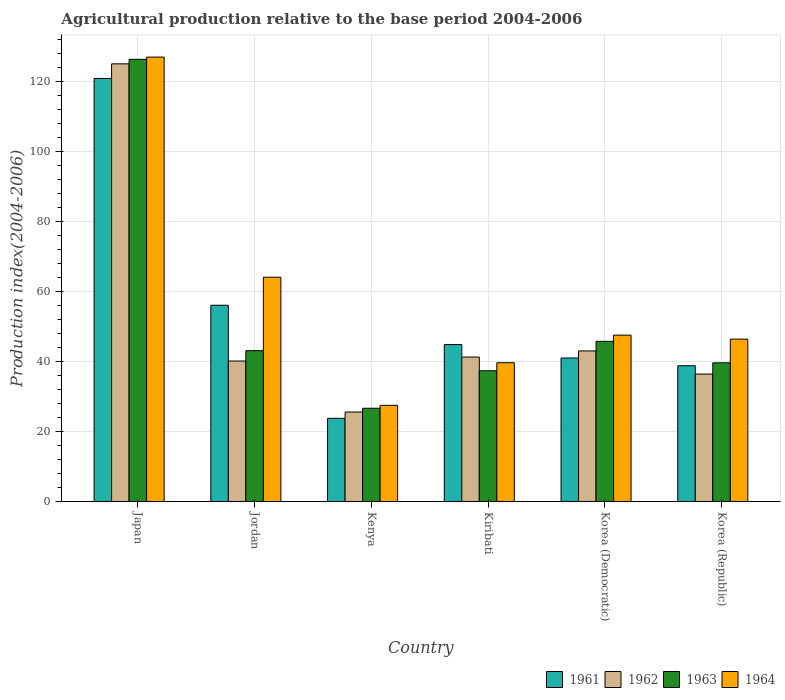How many different coloured bars are there?
Provide a succinct answer. 4. How many bars are there on the 2nd tick from the left?
Provide a short and direct response. 4. What is the label of the 2nd group of bars from the left?
Offer a very short reply. Jordan. Across all countries, what is the maximum agricultural production index in 1964?
Provide a short and direct response. 126.92. Across all countries, what is the minimum agricultural production index in 1964?
Offer a very short reply. 27.46. In which country was the agricultural production index in 1962 minimum?
Give a very brief answer. Kenya. What is the total agricultural production index in 1964 in the graph?
Your answer should be compact. 351.95. What is the difference between the agricultural production index in 1963 in Jordan and that in Korea (Democratic)?
Offer a terse response. -2.67. What is the difference between the agricultural production index in 1962 in Japan and the agricultural production index in 1961 in Korea (Republic)?
Ensure brevity in your answer.  86.22. What is the average agricultural production index in 1962 per country?
Keep it short and to the point. 51.88. What is the difference between the agricultural production index of/in 1962 and agricultural production index of/in 1961 in Korea (Republic)?
Provide a short and direct response. -2.38. What is the ratio of the agricultural production index in 1962 in Japan to that in Jordan?
Provide a short and direct response. 3.12. Is the agricultural production index in 1962 in Japan less than that in Kenya?
Keep it short and to the point. No. What is the difference between the highest and the second highest agricultural production index in 1962?
Your answer should be compact. -1.75. What is the difference between the highest and the lowest agricultural production index in 1961?
Provide a short and direct response. 97.07. Is it the case that in every country, the sum of the agricultural production index in 1963 and agricultural production index in 1962 is greater than the sum of agricultural production index in 1964 and agricultural production index in 1961?
Give a very brief answer. No. What does the 4th bar from the left in Kenya represents?
Provide a short and direct response. 1964. Is it the case that in every country, the sum of the agricultural production index in 1962 and agricultural production index in 1961 is greater than the agricultural production index in 1963?
Your answer should be very brief. Yes. What is the difference between two consecutive major ticks on the Y-axis?
Offer a terse response. 20. Does the graph contain any zero values?
Provide a short and direct response. No. Does the graph contain grids?
Provide a short and direct response. Yes. What is the title of the graph?
Your response must be concise. Agricultural production relative to the base period 2004-2006. Does "1975" appear as one of the legend labels in the graph?
Offer a terse response. No. What is the label or title of the X-axis?
Provide a short and direct response. Country. What is the label or title of the Y-axis?
Ensure brevity in your answer.  Production index(2004-2006). What is the Production index(2004-2006) in 1961 in Japan?
Provide a succinct answer. 120.82. What is the Production index(2004-2006) of 1962 in Japan?
Provide a short and direct response. 124.99. What is the Production index(2004-2006) of 1963 in Japan?
Your answer should be compact. 126.29. What is the Production index(2004-2006) in 1964 in Japan?
Keep it short and to the point. 126.92. What is the Production index(2004-2006) of 1961 in Jordan?
Offer a very short reply. 56.04. What is the Production index(2004-2006) in 1962 in Jordan?
Keep it short and to the point. 40.12. What is the Production index(2004-2006) of 1963 in Jordan?
Provide a short and direct response. 43.07. What is the Production index(2004-2006) of 1964 in Jordan?
Provide a short and direct response. 64.06. What is the Production index(2004-2006) of 1961 in Kenya?
Offer a terse response. 23.75. What is the Production index(2004-2006) in 1962 in Kenya?
Your answer should be compact. 25.55. What is the Production index(2004-2006) in 1963 in Kenya?
Give a very brief answer. 26.63. What is the Production index(2004-2006) of 1964 in Kenya?
Your answer should be very brief. 27.46. What is the Production index(2004-2006) of 1961 in Kiribati?
Your answer should be very brief. 44.81. What is the Production index(2004-2006) of 1962 in Kiribati?
Offer a terse response. 41.25. What is the Production index(2004-2006) in 1963 in Kiribati?
Keep it short and to the point. 37.33. What is the Production index(2004-2006) of 1964 in Kiribati?
Ensure brevity in your answer.  39.63. What is the Production index(2004-2006) in 1961 in Korea (Democratic)?
Your response must be concise. 40.98. What is the Production index(2004-2006) in 1962 in Korea (Democratic)?
Your response must be concise. 43. What is the Production index(2004-2006) of 1963 in Korea (Democratic)?
Keep it short and to the point. 45.74. What is the Production index(2004-2006) in 1964 in Korea (Democratic)?
Offer a terse response. 47.51. What is the Production index(2004-2006) in 1961 in Korea (Republic)?
Offer a very short reply. 38.77. What is the Production index(2004-2006) in 1962 in Korea (Republic)?
Give a very brief answer. 36.39. What is the Production index(2004-2006) of 1963 in Korea (Republic)?
Ensure brevity in your answer.  39.6. What is the Production index(2004-2006) in 1964 in Korea (Republic)?
Your answer should be compact. 46.37. Across all countries, what is the maximum Production index(2004-2006) of 1961?
Your answer should be compact. 120.82. Across all countries, what is the maximum Production index(2004-2006) of 1962?
Keep it short and to the point. 124.99. Across all countries, what is the maximum Production index(2004-2006) in 1963?
Your response must be concise. 126.29. Across all countries, what is the maximum Production index(2004-2006) of 1964?
Provide a short and direct response. 126.92. Across all countries, what is the minimum Production index(2004-2006) in 1961?
Your response must be concise. 23.75. Across all countries, what is the minimum Production index(2004-2006) of 1962?
Ensure brevity in your answer.  25.55. Across all countries, what is the minimum Production index(2004-2006) in 1963?
Your answer should be very brief. 26.63. Across all countries, what is the minimum Production index(2004-2006) in 1964?
Ensure brevity in your answer.  27.46. What is the total Production index(2004-2006) of 1961 in the graph?
Offer a very short reply. 325.17. What is the total Production index(2004-2006) in 1962 in the graph?
Offer a terse response. 311.3. What is the total Production index(2004-2006) of 1963 in the graph?
Offer a terse response. 318.66. What is the total Production index(2004-2006) in 1964 in the graph?
Your answer should be compact. 351.95. What is the difference between the Production index(2004-2006) in 1961 in Japan and that in Jordan?
Offer a terse response. 64.78. What is the difference between the Production index(2004-2006) in 1962 in Japan and that in Jordan?
Keep it short and to the point. 84.87. What is the difference between the Production index(2004-2006) in 1963 in Japan and that in Jordan?
Ensure brevity in your answer.  83.22. What is the difference between the Production index(2004-2006) in 1964 in Japan and that in Jordan?
Offer a terse response. 62.86. What is the difference between the Production index(2004-2006) of 1961 in Japan and that in Kenya?
Your answer should be compact. 97.07. What is the difference between the Production index(2004-2006) in 1962 in Japan and that in Kenya?
Give a very brief answer. 99.44. What is the difference between the Production index(2004-2006) in 1963 in Japan and that in Kenya?
Provide a succinct answer. 99.66. What is the difference between the Production index(2004-2006) in 1964 in Japan and that in Kenya?
Give a very brief answer. 99.46. What is the difference between the Production index(2004-2006) in 1961 in Japan and that in Kiribati?
Offer a very short reply. 76.01. What is the difference between the Production index(2004-2006) of 1962 in Japan and that in Kiribati?
Make the answer very short. 83.74. What is the difference between the Production index(2004-2006) in 1963 in Japan and that in Kiribati?
Ensure brevity in your answer.  88.96. What is the difference between the Production index(2004-2006) of 1964 in Japan and that in Kiribati?
Provide a short and direct response. 87.29. What is the difference between the Production index(2004-2006) of 1961 in Japan and that in Korea (Democratic)?
Offer a terse response. 79.84. What is the difference between the Production index(2004-2006) in 1962 in Japan and that in Korea (Democratic)?
Make the answer very short. 81.99. What is the difference between the Production index(2004-2006) of 1963 in Japan and that in Korea (Democratic)?
Give a very brief answer. 80.55. What is the difference between the Production index(2004-2006) of 1964 in Japan and that in Korea (Democratic)?
Offer a terse response. 79.41. What is the difference between the Production index(2004-2006) in 1961 in Japan and that in Korea (Republic)?
Offer a very short reply. 82.05. What is the difference between the Production index(2004-2006) of 1962 in Japan and that in Korea (Republic)?
Offer a terse response. 88.6. What is the difference between the Production index(2004-2006) of 1963 in Japan and that in Korea (Republic)?
Provide a short and direct response. 86.69. What is the difference between the Production index(2004-2006) of 1964 in Japan and that in Korea (Republic)?
Keep it short and to the point. 80.55. What is the difference between the Production index(2004-2006) in 1961 in Jordan and that in Kenya?
Make the answer very short. 32.29. What is the difference between the Production index(2004-2006) in 1962 in Jordan and that in Kenya?
Provide a short and direct response. 14.57. What is the difference between the Production index(2004-2006) of 1963 in Jordan and that in Kenya?
Your answer should be very brief. 16.44. What is the difference between the Production index(2004-2006) of 1964 in Jordan and that in Kenya?
Ensure brevity in your answer.  36.6. What is the difference between the Production index(2004-2006) in 1961 in Jordan and that in Kiribati?
Ensure brevity in your answer.  11.23. What is the difference between the Production index(2004-2006) of 1962 in Jordan and that in Kiribati?
Your answer should be compact. -1.13. What is the difference between the Production index(2004-2006) of 1963 in Jordan and that in Kiribati?
Provide a succinct answer. 5.74. What is the difference between the Production index(2004-2006) in 1964 in Jordan and that in Kiribati?
Provide a short and direct response. 24.43. What is the difference between the Production index(2004-2006) of 1961 in Jordan and that in Korea (Democratic)?
Provide a succinct answer. 15.06. What is the difference between the Production index(2004-2006) in 1962 in Jordan and that in Korea (Democratic)?
Make the answer very short. -2.88. What is the difference between the Production index(2004-2006) in 1963 in Jordan and that in Korea (Democratic)?
Keep it short and to the point. -2.67. What is the difference between the Production index(2004-2006) in 1964 in Jordan and that in Korea (Democratic)?
Offer a very short reply. 16.55. What is the difference between the Production index(2004-2006) of 1961 in Jordan and that in Korea (Republic)?
Ensure brevity in your answer.  17.27. What is the difference between the Production index(2004-2006) of 1962 in Jordan and that in Korea (Republic)?
Give a very brief answer. 3.73. What is the difference between the Production index(2004-2006) in 1963 in Jordan and that in Korea (Republic)?
Provide a short and direct response. 3.47. What is the difference between the Production index(2004-2006) in 1964 in Jordan and that in Korea (Republic)?
Give a very brief answer. 17.69. What is the difference between the Production index(2004-2006) of 1961 in Kenya and that in Kiribati?
Offer a very short reply. -21.06. What is the difference between the Production index(2004-2006) in 1962 in Kenya and that in Kiribati?
Keep it short and to the point. -15.7. What is the difference between the Production index(2004-2006) in 1964 in Kenya and that in Kiribati?
Offer a terse response. -12.17. What is the difference between the Production index(2004-2006) in 1961 in Kenya and that in Korea (Democratic)?
Offer a terse response. -17.23. What is the difference between the Production index(2004-2006) of 1962 in Kenya and that in Korea (Democratic)?
Ensure brevity in your answer.  -17.45. What is the difference between the Production index(2004-2006) in 1963 in Kenya and that in Korea (Democratic)?
Keep it short and to the point. -19.11. What is the difference between the Production index(2004-2006) of 1964 in Kenya and that in Korea (Democratic)?
Your answer should be very brief. -20.05. What is the difference between the Production index(2004-2006) of 1961 in Kenya and that in Korea (Republic)?
Offer a terse response. -15.02. What is the difference between the Production index(2004-2006) of 1962 in Kenya and that in Korea (Republic)?
Your answer should be very brief. -10.84. What is the difference between the Production index(2004-2006) of 1963 in Kenya and that in Korea (Republic)?
Offer a terse response. -12.97. What is the difference between the Production index(2004-2006) in 1964 in Kenya and that in Korea (Republic)?
Your response must be concise. -18.91. What is the difference between the Production index(2004-2006) in 1961 in Kiribati and that in Korea (Democratic)?
Provide a short and direct response. 3.83. What is the difference between the Production index(2004-2006) in 1962 in Kiribati and that in Korea (Democratic)?
Keep it short and to the point. -1.75. What is the difference between the Production index(2004-2006) in 1963 in Kiribati and that in Korea (Democratic)?
Provide a succinct answer. -8.41. What is the difference between the Production index(2004-2006) in 1964 in Kiribati and that in Korea (Democratic)?
Offer a terse response. -7.88. What is the difference between the Production index(2004-2006) of 1961 in Kiribati and that in Korea (Republic)?
Offer a very short reply. 6.04. What is the difference between the Production index(2004-2006) in 1962 in Kiribati and that in Korea (Republic)?
Make the answer very short. 4.86. What is the difference between the Production index(2004-2006) in 1963 in Kiribati and that in Korea (Republic)?
Your response must be concise. -2.27. What is the difference between the Production index(2004-2006) in 1964 in Kiribati and that in Korea (Republic)?
Provide a succinct answer. -6.74. What is the difference between the Production index(2004-2006) of 1961 in Korea (Democratic) and that in Korea (Republic)?
Your answer should be compact. 2.21. What is the difference between the Production index(2004-2006) in 1962 in Korea (Democratic) and that in Korea (Republic)?
Provide a short and direct response. 6.61. What is the difference between the Production index(2004-2006) in 1963 in Korea (Democratic) and that in Korea (Republic)?
Keep it short and to the point. 6.14. What is the difference between the Production index(2004-2006) in 1964 in Korea (Democratic) and that in Korea (Republic)?
Make the answer very short. 1.14. What is the difference between the Production index(2004-2006) in 1961 in Japan and the Production index(2004-2006) in 1962 in Jordan?
Provide a short and direct response. 80.7. What is the difference between the Production index(2004-2006) in 1961 in Japan and the Production index(2004-2006) in 1963 in Jordan?
Ensure brevity in your answer.  77.75. What is the difference between the Production index(2004-2006) of 1961 in Japan and the Production index(2004-2006) of 1964 in Jordan?
Make the answer very short. 56.76. What is the difference between the Production index(2004-2006) in 1962 in Japan and the Production index(2004-2006) in 1963 in Jordan?
Keep it short and to the point. 81.92. What is the difference between the Production index(2004-2006) of 1962 in Japan and the Production index(2004-2006) of 1964 in Jordan?
Offer a terse response. 60.93. What is the difference between the Production index(2004-2006) in 1963 in Japan and the Production index(2004-2006) in 1964 in Jordan?
Your response must be concise. 62.23. What is the difference between the Production index(2004-2006) of 1961 in Japan and the Production index(2004-2006) of 1962 in Kenya?
Provide a succinct answer. 95.27. What is the difference between the Production index(2004-2006) of 1961 in Japan and the Production index(2004-2006) of 1963 in Kenya?
Provide a succinct answer. 94.19. What is the difference between the Production index(2004-2006) in 1961 in Japan and the Production index(2004-2006) in 1964 in Kenya?
Give a very brief answer. 93.36. What is the difference between the Production index(2004-2006) in 1962 in Japan and the Production index(2004-2006) in 1963 in Kenya?
Make the answer very short. 98.36. What is the difference between the Production index(2004-2006) of 1962 in Japan and the Production index(2004-2006) of 1964 in Kenya?
Your response must be concise. 97.53. What is the difference between the Production index(2004-2006) in 1963 in Japan and the Production index(2004-2006) in 1964 in Kenya?
Ensure brevity in your answer.  98.83. What is the difference between the Production index(2004-2006) in 1961 in Japan and the Production index(2004-2006) in 1962 in Kiribati?
Keep it short and to the point. 79.57. What is the difference between the Production index(2004-2006) of 1961 in Japan and the Production index(2004-2006) of 1963 in Kiribati?
Your answer should be very brief. 83.49. What is the difference between the Production index(2004-2006) in 1961 in Japan and the Production index(2004-2006) in 1964 in Kiribati?
Provide a short and direct response. 81.19. What is the difference between the Production index(2004-2006) of 1962 in Japan and the Production index(2004-2006) of 1963 in Kiribati?
Your answer should be very brief. 87.66. What is the difference between the Production index(2004-2006) of 1962 in Japan and the Production index(2004-2006) of 1964 in Kiribati?
Your answer should be very brief. 85.36. What is the difference between the Production index(2004-2006) of 1963 in Japan and the Production index(2004-2006) of 1964 in Kiribati?
Offer a very short reply. 86.66. What is the difference between the Production index(2004-2006) of 1961 in Japan and the Production index(2004-2006) of 1962 in Korea (Democratic)?
Ensure brevity in your answer.  77.82. What is the difference between the Production index(2004-2006) of 1961 in Japan and the Production index(2004-2006) of 1963 in Korea (Democratic)?
Offer a terse response. 75.08. What is the difference between the Production index(2004-2006) of 1961 in Japan and the Production index(2004-2006) of 1964 in Korea (Democratic)?
Make the answer very short. 73.31. What is the difference between the Production index(2004-2006) of 1962 in Japan and the Production index(2004-2006) of 1963 in Korea (Democratic)?
Your answer should be compact. 79.25. What is the difference between the Production index(2004-2006) of 1962 in Japan and the Production index(2004-2006) of 1964 in Korea (Democratic)?
Make the answer very short. 77.48. What is the difference between the Production index(2004-2006) of 1963 in Japan and the Production index(2004-2006) of 1964 in Korea (Democratic)?
Your answer should be very brief. 78.78. What is the difference between the Production index(2004-2006) of 1961 in Japan and the Production index(2004-2006) of 1962 in Korea (Republic)?
Offer a terse response. 84.43. What is the difference between the Production index(2004-2006) of 1961 in Japan and the Production index(2004-2006) of 1963 in Korea (Republic)?
Make the answer very short. 81.22. What is the difference between the Production index(2004-2006) in 1961 in Japan and the Production index(2004-2006) in 1964 in Korea (Republic)?
Ensure brevity in your answer.  74.45. What is the difference between the Production index(2004-2006) of 1962 in Japan and the Production index(2004-2006) of 1963 in Korea (Republic)?
Your answer should be very brief. 85.39. What is the difference between the Production index(2004-2006) in 1962 in Japan and the Production index(2004-2006) in 1964 in Korea (Republic)?
Give a very brief answer. 78.62. What is the difference between the Production index(2004-2006) in 1963 in Japan and the Production index(2004-2006) in 1964 in Korea (Republic)?
Your answer should be very brief. 79.92. What is the difference between the Production index(2004-2006) of 1961 in Jordan and the Production index(2004-2006) of 1962 in Kenya?
Give a very brief answer. 30.49. What is the difference between the Production index(2004-2006) of 1961 in Jordan and the Production index(2004-2006) of 1963 in Kenya?
Provide a succinct answer. 29.41. What is the difference between the Production index(2004-2006) of 1961 in Jordan and the Production index(2004-2006) of 1964 in Kenya?
Your answer should be very brief. 28.58. What is the difference between the Production index(2004-2006) of 1962 in Jordan and the Production index(2004-2006) of 1963 in Kenya?
Your answer should be compact. 13.49. What is the difference between the Production index(2004-2006) of 1962 in Jordan and the Production index(2004-2006) of 1964 in Kenya?
Provide a short and direct response. 12.66. What is the difference between the Production index(2004-2006) of 1963 in Jordan and the Production index(2004-2006) of 1964 in Kenya?
Provide a succinct answer. 15.61. What is the difference between the Production index(2004-2006) of 1961 in Jordan and the Production index(2004-2006) of 1962 in Kiribati?
Ensure brevity in your answer.  14.79. What is the difference between the Production index(2004-2006) of 1961 in Jordan and the Production index(2004-2006) of 1963 in Kiribati?
Ensure brevity in your answer.  18.71. What is the difference between the Production index(2004-2006) in 1961 in Jordan and the Production index(2004-2006) in 1964 in Kiribati?
Ensure brevity in your answer.  16.41. What is the difference between the Production index(2004-2006) of 1962 in Jordan and the Production index(2004-2006) of 1963 in Kiribati?
Keep it short and to the point. 2.79. What is the difference between the Production index(2004-2006) in 1962 in Jordan and the Production index(2004-2006) in 1964 in Kiribati?
Make the answer very short. 0.49. What is the difference between the Production index(2004-2006) of 1963 in Jordan and the Production index(2004-2006) of 1964 in Kiribati?
Your answer should be very brief. 3.44. What is the difference between the Production index(2004-2006) of 1961 in Jordan and the Production index(2004-2006) of 1962 in Korea (Democratic)?
Your response must be concise. 13.04. What is the difference between the Production index(2004-2006) in 1961 in Jordan and the Production index(2004-2006) in 1963 in Korea (Democratic)?
Offer a terse response. 10.3. What is the difference between the Production index(2004-2006) of 1961 in Jordan and the Production index(2004-2006) of 1964 in Korea (Democratic)?
Offer a very short reply. 8.53. What is the difference between the Production index(2004-2006) of 1962 in Jordan and the Production index(2004-2006) of 1963 in Korea (Democratic)?
Offer a terse response. -5.62. What is the difference between the Production index(2004-2006) of 1962 in Jordan and the Production index(2004-2006) of 1964 in Korea (Democratic)?
Make the answer very short. -7.39. What is the difference between the Production index(2004-2006) in 1963 in Jordan and the Production index(2004-2006) in 1964 in Korea (Democratic)?
Your answer should be compact. -4.44. What is the difference between the Production index(2004-2006) in 1961 in Jordan and the Production index(2004-2006) in 1962 in Korea (Republic)?
Your answer should be very brief. 19.65. What is the difference between the Production index(2004-2006) of 1961 in Jordan and the Production index(2004-2006) of 1963 in Korea (Republic)?
Ensure brevity in your answer.  16.44. What is the difference between the Production index(2004-2006) in 1961 in Jordan and the Production index(2004-2006) in 1964 in Korea (Republic)?
Give a very brief answer. 9.67. What is the difference between the Production index(2004-2006) of 1962 in Jordan and the Production index(2004-2006) of 1963 in Korea (Republic)?
Ensure brevity in your answer.  0.52. What is the difference between the Production index(2004-2006) of 1962 in Jordan and the Production index(2004-2006) of 1964 in Korea (Republic)?
Provide a short and direct response. -6.25. What is the difference between the Production index(2004-2006) in 1963 in Jordan and the Production index(2004-2006) in 1964 in Korea (Republic)?
Provide a succinct answer. -3.3. What is the difference between the Production index(2004-2006) in 1961 in Kenya and the Production index(2004-2006) in 1962 in Kiribati?
Ensure brevity in your answer.  -17.5. What is the difference between the Production index(2004-2006) of 1961 in Kenya and the Production index(2004-2006) of 1963 in Kiribati?
Keep it short and to the point. -13.58. What is the difference between the Production index(2004-2006) of 1961 in Kenya and the Production index(2004-2006) of 1964 in Kiribati?
Your answer should be very brief. -15.88. What is the difference between the Production index(2004-2006) of 1962 in Kenya and the Production index(2004-2006) of 1963 in Kiribati?
Keep it short and to the point. -11.78. What is the difference between the Production index(2004-2006) in 1962 in Kenya and the Production index(2004-2006) in 1964 in Kiribati?
Offer a terse response. -14.08. What is the difference between the Production index(2004-2006) in 1963 in Kenya and the Production index(2004-2006) in 1964 in Kiribati?
Give a very brief answer. -13. What is the difference between the Production index(2004-2006) in 1961 in Kenya and the Production index(2004-2006) in 1962 in Korea (Democratic)?
Your answer should be very brief. -19.25. What is the difference between the Production index(2004-2006) in 1961 in Kenya and the Production index(2004-2006) in 1963 in Korea (Democratic)?
Give a very brief answer. -21.99. What is the difference between the Production index(2004-2006) of 1961 in Kenya and the Production index(2004-2006) of 1964 in Korea (Democratic)?
Ensure brevity in your answer.  -23.76. What is the difference between the Production index(2004-2006) in 1962 in Kenya and the Production index(2004-2006) in 1963 in Korea (Democratic)?
Make the answer very short. -20.19. What is the difference between the Production index(2004-2006) in 1962 in Kenya and the Production index(2004-2006) in 1964 in Korea (Democratic)?
Your answer should be compact. -21.96. What is the difference between the Production index(2004-2006) in 1963 in Kenya and the Production index(2004-2006) in 1964 in Korea (Democratic)?
Offer a terse response. -20.88. What is the difference between the Production index(2004-2006) of 1961 in Kenya and the Production index(2004-2006) of 1962 in Korea (Republic)?
Keep it short and to the point. -12.64. What is the difference between the Production index(2004-2006) in 1961 in Kenya and the Production index(2004-2006) in 1963 in Korea (Republic)?
Offer a terse response. -15.85. What is the difference between the Production index(2004-2006) of 1961 in Kenya and the Production index(2004-2006) of 1964 in Korea (Republic)?
Offer a very short reply. -22.62. What is the difference between the Production index(2004-2006) of 1962 in Kenya and the Production index(2004-2006) of 1963 in Korea (Republic)?
Provide a short and direct response. -14.05. What is the difference between the Production index(2004-2006) of 1962 in Kenya and the Production index(2004-2006) of 1964 in Korea (Republic)?
Give a very brief answer. -20.82. What is the difference between the Production index(2004-2006) of 1963 in Kenya and the Production index(2004-2006) of 1964 in Korea (Republic)?
Keep it short and to the point. -19.74. What is the difference between the Production index(2004-2006) in 1961 in Kiribati and the Production index(2004-2006) in 1962 in Korea (Democratic)?
Provide a succinct answer. 1.81. What is the difference between the Production index(2004-2006) in 1961 in Kiribati and the Production index(2004-2006) in 1963 in Korea (Democratic)?
Give a very brief answer. -0.93. What is the difference between the Production index(2004-2006) of 1962 in Kiribati and the Production index(2004-2006) of 1963 in Korea (Democratic)?
Your answer should be very brief. -4.49. What is the difference between the Production index(2004-2006) of 1962 in Kiribati and the Production index(2004-2006) of 1964 in Korea (Democratic)?
Give a very brief answer. -6.26. What is the difference between the Production index(2004-2006) in 1963 in Kiribati and the Production index(2004-2006) in 1964 in Korea (Democratic)?
Ensure brevity in your answer.  -10.18. What is the difference between the Production index(2004-2006) in 1961 in Kiribati and the Production index(2004-2006) in 1962 in Korea (Republic)?
Offer a very short reply. 8.42. What is the difference between the Production index(2004-2006) of 1961 in Kiribati and the Production index(2004-2006) of 1963 in Korea (Republic)?
Provide a short and direct response. 5.21. What is the difference between the Production index(2004-2006) of 1961 in Kiribati and the Production index(2004-2006) of 1964 in Korea (Republic)?
Ensure brevity in your answer.  -1.56. What is the difference between the Production index(2004-2006) in 1962 in Kiribati and the Production index(2004-2006) in 1963 in Korea (Republic)?
Offer a terse response. 1.65. What is the difference between the Production index(2004-2006) of 1962 in Kiribati and the Production index(2004-2006) of 1964 in Korea (Republic)?
Keep it short and to the point. -5.12. What is the difference between the Production index(2004-2006) of 1963 in Kiribati and the Production index(2004-2006) of 1964 in Korea (Republic)?
Offer a very short reply. -9.04. What is the difference between the Production index(2004-2006) in 1961 in Korea (Democratic) and the Production index(2004-2006) in 1962 in Korea (Republic)?
Your response must be concise. 4.59. What is the difference between the Production index(2004-2006) in 1961 in Korea (Democratic) and the Production index(2004-2006) in 1963 in Korea (Republic)?
Your answer should be compact. 1.38. What is the difference between the Production index(2004-2006) of 1961 in Korea (Democratic) and the Production index(2004-2006) of 1964 in Korea (Republic)?
Offer a very short reply. -5.39. What is the difference between the Production index(2004-2006) in 1962 in Korea (Democratic) and the Production index(2004-2006) in 1964 in Korea (Republic)?
Provide a short and direct response. -3.37. What is the difference between the Production index(2004-2006) of 1963 in Korea (Democratic) and the Production index(2004-2006) of 1964 in Korea (Republic)?
Ensure brevity in your answer.  -0.63. What is the average Production index(2004-2006) of 1961 per country?
Provide a succinct answer. 54.2. What is the average Production index(2004-2006) in 1962 per country?
Give a very brief answer. 51.88. What is the average Production index(2004-2006) in 1963 per country?
Provide a succinct answer. 53.11. What is the average Production index(2004-2006) of 1964 per country?
Provide a succinct answer. 58.66. What is the difference between the Production index(2004-2006) in 1961 and Production index(2004-2006) in 1962 in Japan?
Offer a very short reply. -4.17. What is the difference between the Production index(2004-2006) in 1961 and Production index(2004-2006) in 1963 in Japan?
Your response must be concise. -5.47. What is the difference between the Production index(2004-2006) of 1962 and Production index(2004-2006) of 1963 in Japan?
Make the answer very short. -1.3. What is the difference between the Production index(2004-2006) in 1962 and Production index(2004-2006) in 1964 in Japan?
Make the answer very short. -1.93. What is the difference between the Production index(2004-2006) of 1963 and Production index(2004-2006) of 1964 in Japan?
Your answer should be very brief. -0.63. What is the difference between the Production index(2004-2006) of 1961 and Production index(2004-2006) of 1962 in Jordan?
Your answer should be compact. 15.92. What is the difference between the Production index(2004-2006) of 1961 and Production index(2004-2006) of 1963 in Jordan?
Give a very brief answer. 12.97. What is the difference between the Production index(2004-2006) in 1961 and Production index(2004-2006) in 1964 in Jordan?
Offer a very short reply. -8.02. What is the difference between the Production index(2004-2006) of 1962 and Production index(2004-2006) of 1963 in Jordan?
Provide a short and direct response. -2.95. What is the difference between the Production index(2004-2006) of 1962 and Production index(2004-2006) of 1964 in Jordan?
Ensure brevity in your answer.  -23.94. What is the difference between the Production index(2004-2006) of 1963 and Production index(2004-2006) of 1964 in Jordan?
Offer a very short reply. -20.99. What is the difference between the Production index(2004-2006) of 1961 and Production index(2004-2006) of 1963 in Kenya?
Provide a short and direct response. -2.88. What is the difference between the Production index(2004-2006) in 1961 and Production index(2004-2006) in 1964 in Kenya?
Give a very brief answer. -3.71. What is the difference between the Production index(2004-2006) in 1962 and Production index(2004-2006) in 1963 in Kenya?
Make the answer very short. -1.08. What is the difference between the Production index(2004-2006) of 1962 and Production index(2004-2006) of 1964 in Kenya?
Offer a terse response. -1.91. What is the difference between the Production index(2004-2006) in 1963 and Production index(2004-2006) in 1964 in Kenya?
Your answer should be very brief. -0.83. What is the difference between the Production index(2004-2006) of 1961 and Production index(2004-2006) of 1962 in Kiribati?
Provide a succinct answer. 3.56. What is the difference between the Production index(2004-2006) in 1961 and Production index(2004-2006) in 1963 in Kiribati?
Offer a terse response. 7.48. What is the difference between the Production index(2004-2006) in 1961 and Production index(2004-2006) in 1964 in Kiribati?
Offer a very short reply. 5.18. What is the difference between the Production index(2004-2006) of 1962 and Production index(2004-2006) of 1963 in Kiribati?
Give a very brief answer. 3.92. What is the difference between the Production index(2004-2006) of 1962 and Production index(2004-2006) of 1964 in Kiribati?
Offer a very short reply. 1.62. What is the difference between the Production index(2004-2006) of 1961 and Production index(2004-2006) of 1962 in Korea (Democratic)?
Your response must be concise. -2.02. What is the difference between the Production index(2004-2006) of 1961 and Production index(2004-2006) of 1963 in Korea (Democratic)?
Keep it short and to the point. -4.76. What is the difference between the Production index(2004-2006) in 1961 and Production index(2004-2006) in 1964 in Korea (Democratic)?
Your answer should be very brief. -6.53. What is the difference between the Production index(2004-2006) in 1962 and Production index(2004-2006) in 1963 in Korea (Democratic)?
Give a very brief answer. -2.74. What is the difference between the Production index(2004-2006) in 1962 and Production index(2004-2006) in 1964 in Korea (Democratic)?
Provide a short and direct response. -4.51. What is the difference between the Production index(2004-2006) in 1963 and Production index(2004-2006) in 1964 in Korea (Democratic)?
Offer a very short reply. -1.77. What is the difference between the Production index(2004-2006) in 1961 and Production index(2004-2006) in 1962 in Korea (Republic)?
Your response must be concise. 2.38. What is the difference between the Production index(2004-2006) of 1961 and Production index(2004-2006) of 1963 in Korea (Republic)?
Offer a terse response. -0.83. What is the difference between the Production index(2004-2006) of 1962 and Production index(2004-2006) of 1963 in Korea (Republic)?
Give a very brief answer. -3.21. What is the difference between the Production index(2004-2006) of 1962 and Production index(2004-2006) of 1964 in Korea (Republic)?
Your answer should be very brief. -9.98. What is the difference between the Production index(2004-2006) of 1963 and Production index(2004-2006) of 1964 in Korea (Republic)?
Ensure brevity in your answer.  -6.77. What is the ratio of the Production index(2004-2006) in 1961 in Japan to that in Jordan?
Offer a terse response. 2.16. What is the ratio of the Production index(2004-2006) of 1962 in Japan to that in Jordan?
Provide a short and direct response. 3.12. What is the ratio of the Production index(2004-2006) in 1963 in Japan to that in Jordan?
Your answer should be very brief. 2.93. What is the ratio of the Production index(2004-2006) of 1964 in Japan to that in Jordan?
Offer a terse response. 1.98. What is the ratio of the Production index(2004-2006) in 1961 in Japan to that in Kenya?
Provide a short and direct response. 5.09. What is the ratio of the Production index(2004-2006) in 1962 in Japan to that in Kenya?
Offer a very short reply. 4.89. What is the ratio of the Production index(2004-2006) of 1963 in Japan to that in Kenya?
Provide a short and direct response. 4.74. What is the ratio of the Production index(2004-2006) of 1964 in Japan to that in Kenya?
Ensure brevity in your answer.  4.62. What is the ratio of the Production index(2004-2006) in 1961 in Japan to that in Kiribati?
Your answer should be very brief. 2.7. What is the ratio of the Production index(2004-2006) in 1962 in Japan to that in Kiribati?
Ensure brevity in your answer.  3.03. What is the ratio of the Production index(2004-2006) in 1963 in Japan to that in Kiribati?
Your response must be concise. 3.38. What is the ratio of the Production index(2004-2006) of 1964 in Japan to that in Kiribati?
Make the answer very short. 3.2. What is the ratio of the Production index(2004-2006) of 1961 in Japan to that in Korea (Democratic)?
Your answer should be very brief. 2.95. What is the ratio of the Production index(2004-2006) of 1962 in Japan to that in Korea (Democratic)?
Keep it short and to the point. 2.91. What is the ratio of the Production index(2004-2006) in 1963 in Japan to that in Korea (Democratic)?
Keep it short and to the point. 2.76. What is the ratio of the Production index(2004-2006) in 1964 in Japan to that in Korea (Democratic)?
Provide a short and direct response. 2.67. What is the ratio of the Production index(2004-2006) of 1961 in Japan to that in Korea (Republic)?
Your answer should be very brief. 3.12. What is the ratio of the Production index(2004-2006) in 1962 in Japan to that in Korea (Republic)?
Your response must be concise. 3.43. What is the ratio of the Production index(2004-2006) in 1963 in Japan to that in Korea (Republic)?
Provide a short and direct response. 3.19. What is the ratio of the Production index(2004-2006) in 1964 in Japan to that in Korea (Republic)?
Give a very brief answer. 2.74. What is the ratio of the Production index(2004-2006) in 1961 in Jordan to that in Kenya?
Give a very brief answer. 2.36. What is the ratio of the Production index(2004-2006) of 1962 in Jordan to that in Kenya?
Provide a short and direct response. 1.57. What is the ratio of the Production index(2004-2006) in 1963 in Jordan to that in Kenya?
Your answer should be very brief. 1.62. What is the ratio of the Production index(2004-2006) of 1964 in Jordan to that in Kenya?
Your answer should be very brief. 2.33. What is the ratio of the Production index(2004-2006) in 1961 in Jordan to that in Kiribati?
Your answer should be very brief. 1.25. What is the ratio of the Production index(2004-2006) of 1962 in Jordan to that in Kiribati?
Offer a very short reply. 0.97. What is the ratio of the Production index(2004-2006) in 1963 in Jordan to that in Kiribati?
Offer a very short reply. 1.15. What is the ratio of the Production index(2004-2006) in 1964 in Jordan to that in Kiribati?
Provide a succinct answer. 1.62. What is the ratio of the Production index(2004-2006) in 1961 in Jordan to that in Korea (Democratic)?
Your answer should be compact. 1.37. What is the ratio of the Production index(2004-2006) of 1962 in Jordan to that in Korea (Democratic)?
Your response must be concise. 0.93. What is the ratio of the Production index(2004-2006) in 1963 in Jordan to that in Korea (Democratic)?
Make the answer very short. 0.94. What is the ratio of the Production index(2004-2006) in 1964 in Jordan to that in Korea (Democratic)?
Your response must be concise. 1.35. What is the ratio of the Production index(2004-2006) in 1961 in Jordan to that in Korea (Republic)?
Give a very brief answer. 1.45. What is the ratio of the Production index(2004-2006) in 1962 in Jordan to that in Korea (Republic)?
Provide a succinct answer. 1.1. What is the ratio of the Production index(2004-2006) in 1963 in Jordan to that in Korea (Republic)?
Your answer should be compact. 1.09. What is the ratio of the Production index(2004-2006) in 1964 in Jordan to that in Korea (Republic)?
Your answer should be very brief. 1.38. What is the ratio of the Production index(2004-2006) of 1961 in Kenya to that in Kiribati?
Give a very brief answer. 0.53. What is the ratio of the Production index(2004-2006) of 1962 in Kenya to that in Kiribati?
Give a very brief answer. 0.62. What is the ratio of the Production index(2004-2006) in 1963 in Kenya to that in Kiribati?
Your answer should be compact. 0.71. What is the ratio of the Production index(2004-2006) of 1964 in Kenya to that in Kiribati?
Provide a succinct answer. 0.69. What is the ratio of the Production index(2004-2006) of 1961 in Kenya to that in Korea (Democratic)?
Make the answer very short. 0.58. What is the ratio of the Production index(2004-2006) in 1962 in Kenya to that in Korea (Democratic)?
Offer a terse response. 0.59. What is the ratio of the Production index(2004-2006) of 1963 in Kenya to that in Korea (Democratic)?
Make the answer very short. 0.58. What is the ratio of the Production index(2004-2006) in 1964 in Kenya to that in Korea (Democratic)?
Offer a very short reply. 0.58. What is the ratio of the Production index(2004-2006) of 1961 in Kenya to that in Korea (Republic)?
Your response must be concise. 0.61. What is the ratio of the Production index(2004-2006) of 1962 in Kenya to that in Korea (Republic)?
Your response must be concise. 0.7. What is the ratio of the Production index(2004-2006) in 1963 in Kenya to that in Korea (Republic)?
Provide a short and direct response. 0.67. What is the ratio of the Production index(2004-2006) in 1964 in Kenya to that in Korea (Republic)?
Your answer should be very brief. 0.59. What is the ratio of the Production index(2004-2006) in 1961 in Kiribati to that in Korea (Democratic)?
Provide a succinct answer. 1.09. What is the ratio of the Production index(2004-2006) of 1962 in Kiribati to that in Korea (Democratic)?
Keep it short and to the point. 0.96. What is the ratio of the Production index(2004-2006) in 1963 in Kiribati to that in Korea (Democratic)?
Make the answer very short. 0.82. What is the ratio of the Production index(2004-2006) of 1964 in Kiribati to that in Korea (Democratic)?
Your answer should be compact. 0.83. What is the ratio of the Production index(2004-2006) in 1961 in Kiribati to that in Korea (Republic)?
Your answer should be compact. 1.16. What is the ratio of the Production index(2004-2006) of 1962 in Kiribati to that in Korea (Republic)?
Your response must be concise. 1.13. What is the ratio of the Production index(2004-2006) in 1963 in Kiribati to that in Korea (Republic)?
Make the answer very short. 0.94. What is the ratio of the Production index(2004-2006) in 1964 in Kiribati to that in Korea (Republic)?
Keep it short and to the point. 0.85. What is the ratio of the Production index(2004-2006) in 1961 in Korea (Democratic) to that in Korea (Republic)?
Offer a very short reply. 1.06. What is the ratio of the Production index(2004-2006) of 1962 in Korea (Democratic) to that in Korea (Republic)?
Your answer should be very brief. 1.18. What is the ratio of the Production index(2004-2006) of 1963 in Korea (Democratic) to that in Korea (Republic)?
Offer a very short reply. 1.16. What is the ratio of the Production index(2004-2006) of 1964 in Korea (Democratic) to that in Korea (Republic)?
Offer a very short reply. 1.02. What is the difference between the highest and the second highest Production index(2004-2006) of 1961?
Your response must be concise. 64.78. What is the difference between the highest and the second highest Production index(2004-2006) of 1962?
Offer a terse response. 81.99. What is the difference between the highest and the second highest Production index(2004-2006) in 1963?
Offer a terse response. 80.55. What is the difference between the highest and the second highest Production index(2004-2006) of 1964?
Provide a short and direct response. 62.86. What is the difference between the highest and the lowest Production index(2004-2006) in 1961?
Offer a terse response. 97.07. What is the difference between the highest and the lowest Production index(2004-2006) of 1962?
Offer a terse response. 99.44. What is the difference between the highest and the lowest Production index(2004-2006) of 1963?
Your response must be concise. 99.66. What is the difference between the highest and the lowest Production index(2004-2006) of 1964?
Make the answer very short. 99.46. 